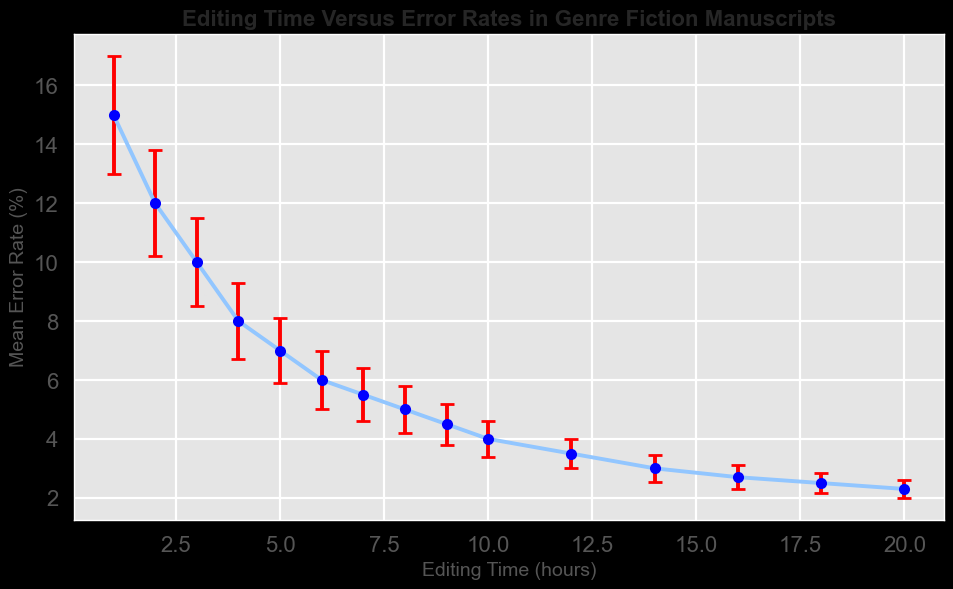How many hours of editing are required for the error rate to drop below 5%? To determine this, examine the graph, noting where the error rate falls below 5%. This occurs after 7 hours of editing. Therefore, editing needs to be done for more than 7 hours to achieve an error rate below 5%.
Answer: More than 7 hours How much does the mean error rate decrease from 1 hour to 10 hours of editing? First, find the mean error rate at 1 hour, which is 15%. Then, find it at 10 hours, which is 4%. Subtract the latter from the former: \(15 - 4 = 11\). The mean error rate decreases by 11%.
Answer: 11% For how many hours of editing do the error bars overlap between 3 and 6 hours of editing? Observe the error bars around the mean error rates for 3 and 6 hours. The error bars for 3 hours range from 8.5% to 11.5%, and for 6 hours, they range from 5% to 7%. There's no overlap between these ranges.
Answer: No overlap At what rate does the error rate decrease from 5 to 10 hours of editing? Calculate the mean error rate at 5 hours (7%) and at 10 hours (4%). Find the difference: \(7 - 4 = 3\). The time difference is 5 hours. The rate of decrease is \(\frac{3}{5} = 0.6\% \text{ per hour}\).
Answer: 0.6% per hour Is there a point where increased editing time results in smaller reductions in error rates? Compare the slopes of the line segments in the plot. Early on, the error rates decrease rapidly. Later, especially after 12 hours, the slope lessens, indicating smaller reductions. Verify by checking the graphical slopes or values. From 12 hours onward, the reduction becomes less steep.
Answer: After 12 hours Which editing time has the smallest error bars? Check the length of the error bars across the plotted points. The shortest error bars are at the 20-hour mark, indicating the smallest standard deviation.
Answer: 20 hours By how much does the mean error rate decrease from 14 hours to 18 hours of editing, and what’s the rate of this decrease? Note the mean error rate at 14 hours (3%) and at 18 hours (2.5%). Subtract \(3 - 2.5 = 0.5\). The time difference is 4 hours, so the rate is \(\frac{0.5}{4} = 0.125\% \text{ per hour}\).
Answer: 0.125% per hour Between which consecutive hours does the largest drop in mean error rate occur? Observe the differences between consecutive mean error rates. The largest drop is from 1 hour (15%) to 2 hours (12%), a difference of 3%.
Answer: 1 to 2 hours How does the magnitude of the error bars change over time? Examine the plot and notice the length of the error bars decreasing over time. The largest error bars are at the beginning and reduce as editing time increases.
Answer: Decreases over time 